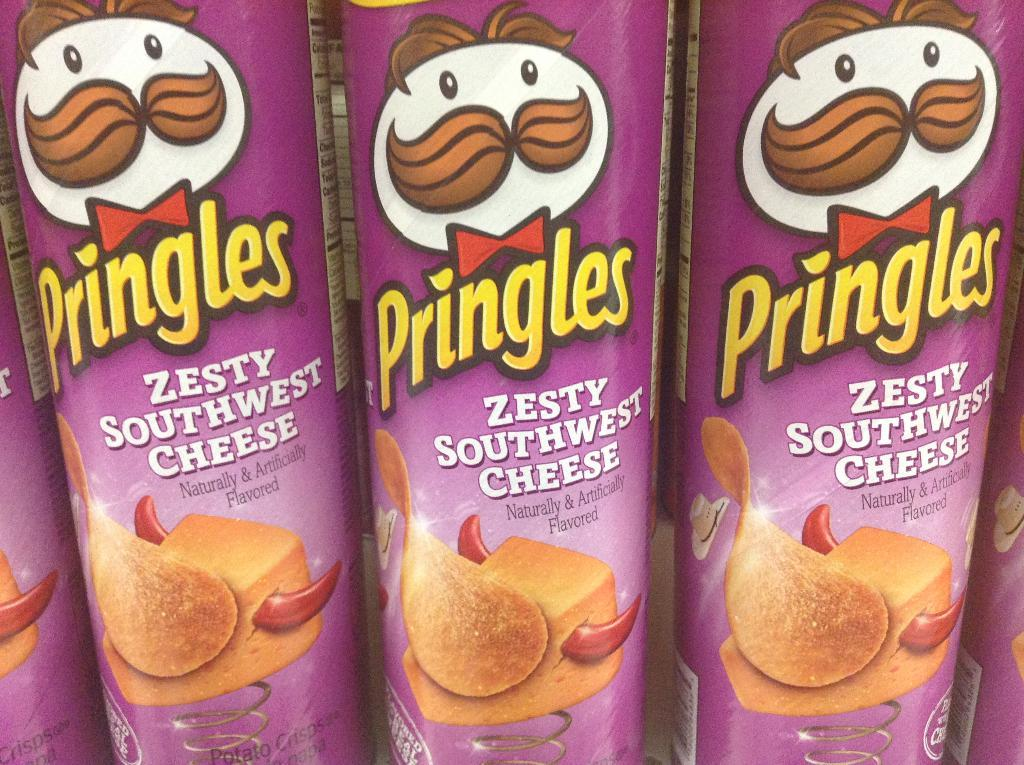What objects are present in the image? There are boxes in the image. What decorations are on the boxes? There are bow ties and caps on the boxes. What other features can be seen on the boxes? There are springs on the boxes. What type of property is being managed by the organization in the image? There is no reference to any property, organization, or management in the image; it only features boxes with bow ties, caps, and springs. 